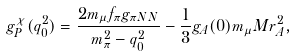<formula> <loc_0><loc_0><loc_500><loc_500>g ^ { \chi } _ { P } ( q ^ { 2 } _ { 0 } ) = \frac { 2 m _ { \mu } f _ { \pi } g _ { \pi N N } } { m ^ { 2 } _ { \pi } - q ^ { 2 } _ { 0 } } - \frac { 1 } { 3 } g _ { A } ( 0 ) m _ { \mu } M r ^ { 2 } _ { A } ,</formula> 